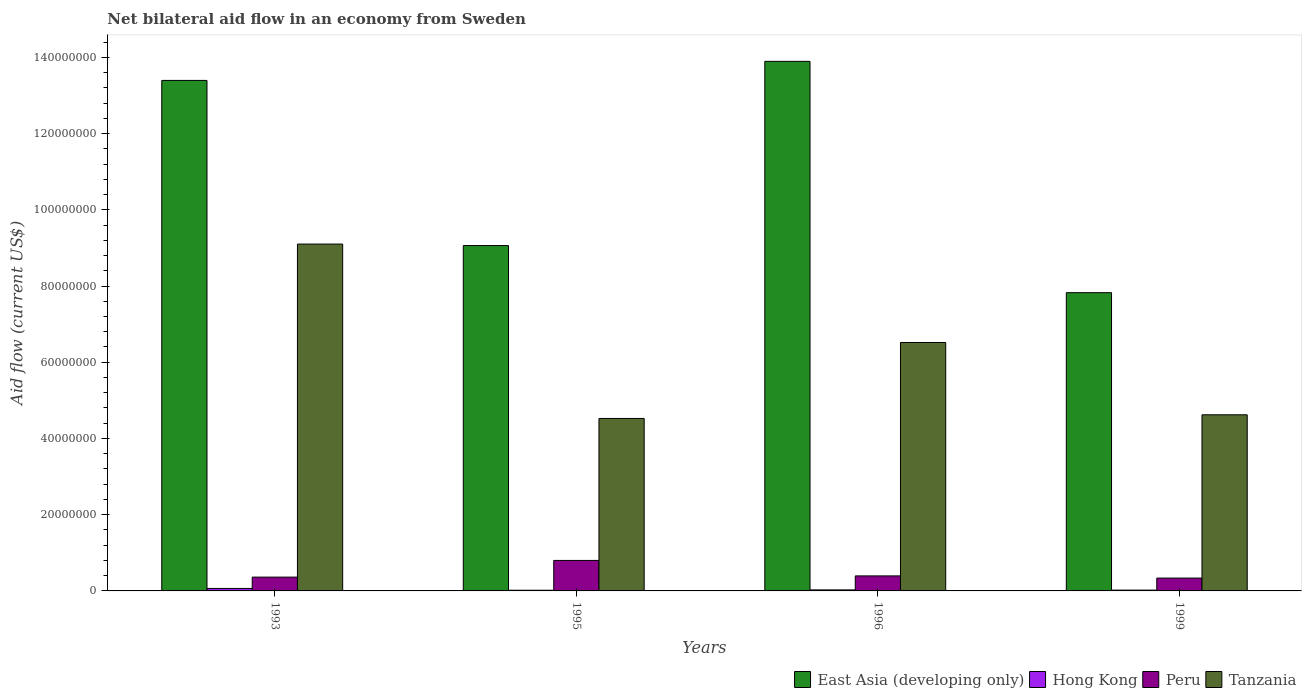How many different coloured bars are there?
Make the answer very short. 4. Are the number of bars per tick equal to the number of legend labels?
Your response must be concise. Yes. Are the number of bars on each tick of the X-axis equal?
Your answer should be very brief. Yes. How many bars are there on the 3rd tick from the left?
Offer a terse response. 4. What is the label of the 4th group of bars from the left?
Your answer should be very brief. 1999. What is the net bilateral aid flow in East Asia (developing only) in 1996?
Keep it short and to the point. 1.39e+08. Across all years, what is the maximum net bilateral aid flow in Peru?
Ensure brevity in your answer.  8.00e+06. Across all years, what is the minimum net bilateral aid flow in East Asia (developing only)?
Provide a succinct answer. 7.82e+07. What is the total net bilateral aid flow in East Asia (developing only) in the graph?
Offer a terse response. 4.42e+08. What is the difference between the net bilateral aid flow in East Asia (developing only) in 1995 and that in 1999?
Keep it short and to the point. 1.24e+07. What is the difference between the net bilateral aid flow in Tanzania in 1993 and the net bilateral aid flow in Hong Kong in 1996?
Your answer should be very brief. 9.07e+07. What is the average net bilateral aid flow in Peru per year?
Your answer should be very brief. 4.73e+06. In the year 1996, what is the difference between the net bilateral aid flow in Peru and net bilateral aid flow in Tanzania?
Your answer should be compact. -6.12e+07. What is the ratio of the net bilateral aid flow in Tanzania in 1993 to that in 1995?
Offer a very short reply. 2.01. What is the difference between the highest and the lowest net bilateral aid flow in Hong Kong?
Offer a terse response. 4.70e+05. Is the sum of the net bilateral aid flow in East Asia (developing only) in 1995 and 1996 greater than the maximum net bilateral aid flow in Peru across all years?
Give a very brief answer. Yes. What does the 1st bar from the left in 1995 represents?
Your response must be concise. East Asia (developing only). What does the 3rd bar from the right in 1995 represents?
Your answer should be compact. Hong Kong. How many bars are there?
Offer a very short reply. 16. How many years are there in the graph?
Your answer should be compact. 4. Are the values on the major ticks of Y-axis written in scientific E-notation?
Make the answer very short. No. Where does the legend appear in the graph?
Your response must be concise. Bottom right. How are the legend labels stacked?
Provide a succinct answer. Horizontal. What is the title of the graph?
Offer a terse response. Net bilateral aid flow in an economy from Sweden. Does "Bhutan" appear as one of the legend labels in the graph?
Give a very brief answer. No. What is the label or title of the Y-axis?
Provide a succinct answer. Aid flow (current US$). What is the Aid flow (current US$) of East Asia (developing only) in 1993?
Your answer should be very brief. 1.34e+08. What is the Aid flow (current US$) of Hong Kong in 1993?
Offer a terse response. 6.50e+05. What is the Aid flow (current US$) of Peru in 1993?
Provide a short and direct response. 3.62e+06. What is the Aid flow (current US$) of Tanzania in 1993?
Provide a succinct answer. 9.10e+07. What is the Aid flow (current US$) in East Asia (developing only) in 1995?
Your answer should be very brief. 9.06e+07. What is the Aid flow (current US$) in Hong Kong in 1995?
Your answer should be compact. 1.80e+05. What is the Aid flow (current US$) of Peru in 1995?
Give a very brief answer. 8.00e+06. What is the Aid flow (current US$) in Tanzania in 1995?
Your answer should be very brief. 4.52e+07. What is the Aid flow (current US$) of East Asia (developing only) in 1996?
Offer a terse response. 1.39e+08. What is the Aid flow (current US$) of Peru in 1996?
Your answer should be compact. 3.94e+06. What is the Aid flow (current US$) in Tanzania in 1996?
Provide a short and direct response. 6.52e+07. What is the Aid flow (current US$) in East Asia (developing only) in 1999?
Your answer should be very brief. 7.82e+07. What is the Aid flow (current US$) of Hong Kong in 1999?
Offer a terse response. 2.10e+05. What is the Aid flow (current US$) in Peru in 1999?
Offer a very short reply. 3.37e+06. What is the Aid flow (current US$) in Tanzania in 1999?
Give a very brief answer. 4.62e+07. Across all years, what is the maximum Aid flow (current US$) of East Asia (developing only)?
Your answer should be very brief. 1.39e+08. Across all years, what is the maximum Aid flow (current US$) of Hong Kong?
Your answer should be very brief. 6.50e+05. Across all years, what is the maximum Aid flow (current US$) of Peru?
Your answer should be very brief. 8.00e+06. Across all years, what is the maximum Aid flow (current US$) of Tanzania?
Your response must be concise. 9.10e+07. Across all years, what is the minimum Aid flow (current US$) in East Asia (developing only)?
Make the answer very short. 7.82e+07. Across all years, what is the minimum Aid flow (current US$) in Peru?
Your answer should be compact. 3.37e+06. Across all years, what is the minimum Aid flow (current US$) in Tanzania?
Your answer should be compact. 4.52e+07. What is the total Aid flow (current US$) of East Asia (developing only) in the graph?
Your response must be concise. 4.42e+08. What is the total Aid flow (current US$) of Hong Kong in the graph?
Your answer should be compact. 1.31e+06. What is the total Aid flow (current US$) in Peru in the graph?
Make the answer very short. 1.89e+07. What is the total Aid flow (current US$) of Tanzania in the graph?
Give a very brief answer. 2.48e+08. What is the difference between the Aid flow (current US$) in East Asia (developing only) in 1993 and that in 1995?
Your answer should be compact. 4.33e+07. What is the difference between the Aid flow (current US$) in Peru in 1993 and that in 1995?
Give a very brief answer. -4.38e+06. What is the difference between the Aid flow (current US$) in Tanzania in 1993 and that in 1995?
Provide a short and direct response. 4.58e+07. What is the difference between the Aid flow (current US$) of East Asia (developing only) in 1993 and that in 1996?
Keep it short and to the point. -5.00e+06. What is the difference between the Aid flow (current US$) of Hong Kong in 1993 and that in 1996?
Make the answer very short. 3.80e+05. What is the difference between the Aid flow (current US$) of Peru in 1993 and that in 1996?
Provide a succinct answer. -3.20e+05. What is the difference between the Aid flow (current US$) of Tanzania in 1993 and that in 1996?
Keep it short and to the point. 2.58e+07. What is the difference between the Aid flow (current US$) in East Asia (developing only) in 1993 and that in 1999?
Your answer should be compact. 5.57e+07. What is the difference between the Aid flow (current US$) in Peru in 1993 and that in 1999?
Make the answer very short. 2.50e+05. What is the difference between the Aid flow (current US$) of Tanzania in 1993 and that in 1999?
Offer a very short reply. 4.48e+07. What is the difference between the Aid flow (current US$) of East Asia (developing only) in 1995 and that in 1996?
Make the answer very short. -4.83e+07. What is the difference between the Aid flow (current US$) in Peru in 1995 and that in 1996?
Offer a very short reply. 4.06e+06. What is the difference between the Aid flow (current US$) of Tanzania in 1995 and that in 1996?
Provide a short and direct response. -1.99e+07. What is the difference between the Aid flow (current US$) in East Asia (developing only) in 1995 and that in 1999?
Ensure brevity in your answer.  1.24e+07. What is the difference between the Aid flow (current US$) in Hong Kong in 1995 and that in 1999?
Offer a very short reply. -3.00e+04. What is the difference between the Aid flow (current US$) of Peru in 1995 and that in 1999?
Provide a succinct answer. 4.63e+06. What is the difference between the Aid flow (current US$) in Tanzania in 1995 and that in 1999?
Your answer should be compact. -9.60e+05. What is the difference between the Aid flow (current US$) in East Asia (developing only) in 1996 and that in 1999?
Keep it short and to the point. 6.07e+07. What is the difference between the Aid flow (current US$) of Peru in 1996 and that in 1999?
Your answer should be compact. 5.70e+05. What is the difference between the Aid flow (current US$) in Tanzania in 1996 and that in 1999?
Your response must be concise. 1.90e+07. What is the difference between the Aid flow (current US$) in East Asia (developing only) in 1993 and the Aid flow (current US$) in Hong Kong in 1995?
Your answer should be compact. 1.34e+08. What is the difference between the Aid flow (current US$) of East Asia (developing only) in 1993 and the Aid flow (current US$) of Peru in 1995?
Give a very brief answer. 1.26e+08. What is the difference between the Aid flow (current US$) in East Asia (developing only) in 1993 and the Aid flow (current US$) in Tanzania in 1995?
Your answer should be very brief. 8.87e+07. What is the difference between the Aid flow (current US$) of Hong Kong in 1993 and the Aid flow (current US$) of Peru in 1995?
Make the answer very short. -7.35e+06. What is the difference between the Aid flow (current US$) of Hong Kong in 1993 and the Aid flow (current US$) of Tanzania in 1995?
Offer a very short reply. -4.46e+07. What is the difference between the Aid flow (current US$) of Peru in 1993 and the Aid flow (current US$) of Tanzania in 1995?
Give a very brief answer. -4.16e+07. What is the difference between the Aid flow (current US$) of East Asia (developing only) in 1993 and the Aid flow (current US$) of Hong Kong in 1996?
Your answer should be very brief. 1.34e+08. What is the difference between the Aid flow (current US$) of East Asia (developing only) in 1993 and the Aid flow (current US$) of Peru in 1996?
Your answer should be very brief. 1.30e+08. What is the difference between the Aid flow (current US$) of East Asia (developing only) in 1993 and the Aid flow (current US$) of Tanzania in 1996?
Provide a succinct answer. 6.88e+07. What is the difference between the Aid flow (current US$) in Hong Kong in 1993 and the Aid flow (current US$) in Peru in 1996?
Offer a very short reply. -3.29e+06. What is the difference between the Aid flow (current US$) in Hong Kong in 1993 and the Aid flow (current US$) in Tanzania in 1996?
Ensure brevity in your answer.  -6.45e+07. What is the difference between the Aid flow (current US$) of Peru in 1993 and the Aid flow (current US$) of Tanzania in 1996?
Keep it short and to the point. -6.16e+07. What is the difference between the Aid flow (current US$) in East Asia (developing only) in 1993 and the Aid flow (current US$) in Hong Kong in 1999?
Your response must be concise. 1.34e+08. What is the difference between the Aid flow (current US$) of East Asia (developing only) in 1993 and the Aid flow (current US$) of Peru in 1999?
Offer a very short reply. 1.31e+08. What is the difference between the Aid flow (current US$) of East Asia (developing only) in 1993 and the Aid flow (current US$) of Tanzania in 1999?
Offer a very short reply. 8.77e+07. What is the difference between the Aid flow (current US$) in Hong Kong in 1993 and the Aid flow (current US$) in Peru in 1999?
Provide a short and direct response. -2.72e+06. What is the difference between the Aid flow (current US$) of Hong Kong in 1993 and the Aid flow (current US$) of Tanzania in 1999?
Keep it short and to the point. -4.56e+07. What is the difference between the Aid flow (current US$) in Peru in 1993 and the Aid flow (current US$) in Tanzania in 1999?
Keep it short and to the point. -4.26e+07. What is the difference between the Aid flow (current US$) in East Asia (developing only) in 1995 and the Aid flow (current US$) in Hong Kong in 1996?
Your response must be concise. 9.03e+07. What is the difference between the Aid flow (current US$) of East Asia (developing only) in 1995 and the Aid flow (current US$) of Peru in 1996?
Your response must be concise. 8.67e+07. What is the difference between the Aid flow (current US$) in East Asia (developing only) in 1995 and the Aid flow (current US$) in Tanzania in 1996?
Your answer should be very brief. 2.54e+07. What is the difference between the Aid flow (current US$) in Hong Kong in 1995 and the Aid flow (current US$) in Peru in 1996?
Give a very brief answer. -3.76e+06. What is the difference between the Aid flow (current US$) in Hong Kong in 1995 and the Aid flow (current US$) in Tanzania in 1996?
Your answer should be compact. -6.50e+07. What is the difference between the Aid flow (current US$) in Peru in 1995 and the Aid flow (current US$) in Tanzania in 1996?
Your answer should be compact. -5.72e+07. What is the difference between the Aid flow (current US$) of East Asia (developing only) in 1995 and the Aid flow (current US$) of Hong Kong in 1999?
Keep it short and to the point. 9.04e+07. What is the difference between the Aid flow (current US$) of East Asia (developing only) in 1995 and the Aid flow (current US$) of Peru in 1999?
Provide a short and direct response. 8.72e+07. What is the difference between the Aid flow (current US$) of East Asia (developing only) in 1995 and the Aid flow (current US$) of Tanzania in 1999?
Give a very brief answer. 4.44e+07. What is the difference between the Aid flow (current US$) of Hong Kong in 1995 and the Aid flow (current US$) of Peru in 1999?
Ensure brevity in your answer.  -3.19e+06. What is the difference between the Aid flow (current US$) in Hong Kong in 1995 and the Aid flow (current US$) in Tanzania in 1999?
Ensure brevity in your answer.  -4.60e+07. What is the difference between the Aid flow (current US$) in Peru in 1995 and the Aid flow (current US$) in Tanzania in 1999?
Your response must be concise. -3.82e+07. What is the difference between the Aid flow (current US$) in East Asia (developing only) in 1996 and the Aid flow (current US$) in Hong Kong in 1999?
Your answer should be very brief. 1.39e+08. What is the difference between the Aid flow (current US$) of East Asia (developing only) in 1996 and the Aid flow (current US$) of Peru in 1999?
Give a very brief answer. 1.36e+08. What is the difference between the Aid flow (current US$) in East Asia (developing only) in 1996 and the Aid flow (current US$) in Tanzania in 1999?
Provide a succinct answer. 9.27e+07. What is the difference between the Aid flow (current US$) in Hong Kong in 1996 and the Aid flow (current US$) in Peru in 1999?
Ensure brevity in your answer.  -3.10e+06. What is the difference between the Aid flow (current US$) in Hong Kong in 1996 and the Aid flow (current US$) in Tanzania in 1999?
Offer a very short reply. -4.59e+07. What is the difference between the Aid flow (current US$) of Peru in 1996 and the Aid flow (current US$) of Tanzania in 1999?
Give a very brief answer. -4.23e+07. What is the average Aid flow (current US$) of East Asia (developing only) per year?
Keep it short and to the point. 1.10e+08. What is the average Aid flow (current US$) of Hong Kong per year?
Make the answer very short. 3.28e+05. What is the average Aid flow (current US$) of Peru per year?
Your answer should be compact. 4.73e+06. What is the average Aid flow (current US$) of Tanzania per year?
Give a very brief answer. 6.19e+07. In the year 1993, what is the difference between the Aid flow (current US$) in East Asia (developing only) and Aid flow (current US$) in Hong Kong?
Your answer should be compact. 1.33e+08. In the year 1993, what is the difference between the Aid flow (current US$) of East Asia (developing only) and Aid flow (current US$) of Peru?
Ensure brevity in your answer.  1.30e+08. In the year 1993, what is the difference between the Aid flow (current US$) of East Asia (developing only) and Aid flow (current US$) of Tanzania?
Provide a succinct answer. 4.29e+07. In the year 1993, what is the difference between the Aid flow (current US$) of Hong Kong and Aid flow (current US$) of Peru?
Provide a short and direct response. -2.97e+06. In the year 1993, what is the difference between the Aid flow (current US$) of Hong Kong and Aid flow (current US$) of Tanzania?
Ensure brevity in your answer.  -9.04e+07. In the year 1993, what is the difference between the Aid flow (current US$) of Peru and Aid flow (current US$) of Tanzania?
Give a very brief answer. -8.74e+07. In the year 1995, what is the difference between the Aid flow (current US$) of East Asia (developing only) and Aid flow (current US$) of Hong Kong?
Offer a very short reply. 9.04e+07. In the year 1995, what is the difference between the Aid flow (current US$) in East Asia (developing only) and Aid flow (current US$) in Peru?
Your answer should be compact. 8.26e+07. In the year 1995, what is the difference between the Aid flow (current US$) of East Asia (developing only) and Aid flow (current US$) of Tanzania?
Your response must be concise. 4.54e+07. In the year 1995, what is the difference between the Aid flow (current US$) of Hong Kong and Aid flow (current US$) of Peru?
Offer a terse response. -7.82e+06. In the year 1995, what is the difference between the Aid flow (current US$) of Hong Kong and Aid flow (current US$) of Tanzania?
Provide a succinct answer. -4.51e+07. In the year 1995, what is the difference between the Aid flow (current US$) of Peru and Aid flow (current US$) of Tanzania?
Provide a succinct answer. -3.72e+07. In the year 1996, what is the difference between the Aid flow (current US$) in East Asia (developing only) and Aid flow (current US$) in Hong Kong?
Your answer should be compact. 1.39e+08. In the year 1996, what is the difference between the Aid flow (current US$) of East Asia (developing only) and Aid flow (current US$) of Peru?
Offer a terse response. 1.35e+08. In the year 1996, what is the difference between the Aid flow (current US$) in East Asia (developing only) and Aid flow (current US$) in Tanzania?
Provide a short and direct response. 7.38e+07. In the year 1996, what is the difference between the Aid flow (current US$) of Hong Kong and Aid flow (current US$) of Peru?
Ensure brevity in your answer.  -3.67e+06. In the year 1996, what is the difference between the Aid flow (current US$) in Hong Kong and Aid flow (current US$) in Tanzania?
Provide a succinct answer. -6.49e+07. In the year 1996, what is the difference between the Aid flow (current US$) of Peru and Aid flow (current US$) of Tanzania?
Your response must be concise. -6.12e+07. In the year 1999, what is the difference between the Aid flow (current US$) of East Asia (developing only) and Aid flow (current US$) of Hong Kong?
Ensure brevity in your answer.  7.80e+07. In the year 1999, what is the difference between the Aid flow (current US$) in East Asia (developing only) and Aid flow (current US$) in Peru?
Offer a terse response. 7.49e+07. In the year 1999, what is the difference between the Aid flow (current US$) in East Asia (developing only) and Aid flow (current US$) in Tanzania?
Make the answer very short. 3.20e+07. In the year 1999, what is the difference between the Aid flow (current US$) of Hong Kong and Aid flow (current US$) of Peru?
Your answer should be very brief. -3.16e+06. In the year 1999, what is the difference between the Aid flow (current US$) of Hong Kong and Aid flow (current US$) of Tanzania?
Ensure brevity in your answer.  -4.60e+07. In the year 1999, what is the difference between the Aid flow (current US$) of Peru and Aid flow (current US$) of Tanzania?
Your answer should be compact. -4.28e+07. What is the ratio of the Aid flow (current US$) in East Asia (developing only) in 1993 to that in 1995?
Your response must be concise. 1.48. What is the ratio of the Aid flow (current US$) of Hong Kong in 1993 to that in 1995?
Provide a short and direct response. 3.61. What is the ratio of the Aid flow (current US$) of Peru in 1993 to that in 1995?
Make the answer very short. 0.45. What is the ratio of the Aid flow (current US$) of Tanzania in 1993 to that in 1995?
Ensure brevity in your answer.  2.01. What is the ratio of the Aid flow (current US$) of East Asia (developing only) in 1993 to that in 1996?
Offer a terse response. 0.96. What is the ratio of the Aid flow (current US$) of Hong Kong in 1993 to that in 1996?
Give a very brief answer. 2.41. What is the ratio of the Aid flow (current US$) in Peru in 1993 to that in 1996?
Offer a terse response. 0.92. What is the ratio of the Aid flow (current US$) in Tanzania in 1993 to that in 1996?
Give a very brief answer. 1.4. What is the ratio of the Aid flow (current US$) in East Asia (developing only) in 1993 to that in 1999?
Keep it short and to the point. 1.71. What is the ratio of the Aid flow (current US$) of Hong Kong in 1993 to that in 1999?
Ensure brevity in your answer.  3.1. What is the ratio of the Aid flow (current US$) of Peru in 1993 to that in 1999?
Make the answer very short. 1.07. What is the ratio of the Aid flow (current US$) of Tanzania in 1993 to that in 1999?
Make the answer very short. 1.97. What is the ratio of the Aid flow (current US$) of East Asia (developing only) in 1995 to that in 1996?
Ensure brevity in your answer.  0.65. What is the ratio of the Aid flow (current US$) of Hong Kong in 1995 to that in 1996?
Your answer should be compact. 0.67. What is the ratio of the Aid flow (current US$) of Peru in 1995 to that in 1996?
Your answer should be compact. 2.03. What is the ratio of the Aid flow (current US$) of Tanzania in 1995 to that in 1996?
Offer a terse response. 0.69. What is the ratio of the Aid flow (current US$) in East Asia (developing only) in 1995 to that in 1999?
Your response must be concise. 1.16. What is the ratio of the Aid flow (current US$) in Hong Kong in 1995 to that in 1999?
Your answer should be compact. 0.86. What is the ratio of the Aid flow (current US$) of Peru in 1995 to that in 1999?
Your answer should be very brief. 2.37. What is the ratio of the Aid flow (current US$) of Tanzania in 1995 to that in 1999?
Provide a succinct answer. 0.98. What is the ratio of the Aid flow (current US$) in East Asia (developing only) in 1996 to that in 1999?
Make the answer very short. 1.78. What is the ratio of the Aid flow (current US$) of Peru in 1996 to that in 1999?
Provide a succinct answer. 1.17. What is the ratio of the Aid flow (current US$) in Tanzania in 1996 to that in 1999?
Give a very brief answer. 1.41. What is the difference between the highest and the second highest Aid flow (current US$) of Peru?
Offer a terse response. 4.06e+06. What is the difference between the highest and the second highest Aid flow (current US$) of Tanzania?
Provide a succinct answer. 2.58e+07. What is the difference between the highest and the lowest Aid flow (current US$) of East Asia (developing only)?
Make the answer very short. 6.07e+07. What is the difference between the highest and the lowest Aid flow (current US$) of Hong Kong?
Ensure brevity in your answer.  4.70e+05. What is the difference between the highest and the lowest Aid flow (current US$) in Peru?
Provide a succinct answer. 4.63e+06. What is the difference between the highest and the lowest Aid flow (current US$) in Tanzania?
Give a very brief answer. 4.58e+07. 